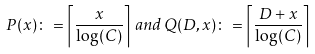<formula> <loc_0><loc_0><loc_500><loc_500>P ( x ) \colon = \left \lceil \frac { x } { \log ( C ) } \right \rceil \, a n d \, Q ( D , x ) \colon = \left \lceil \frac { D + x } { \log ( C ) } \right \rceil</formula> 